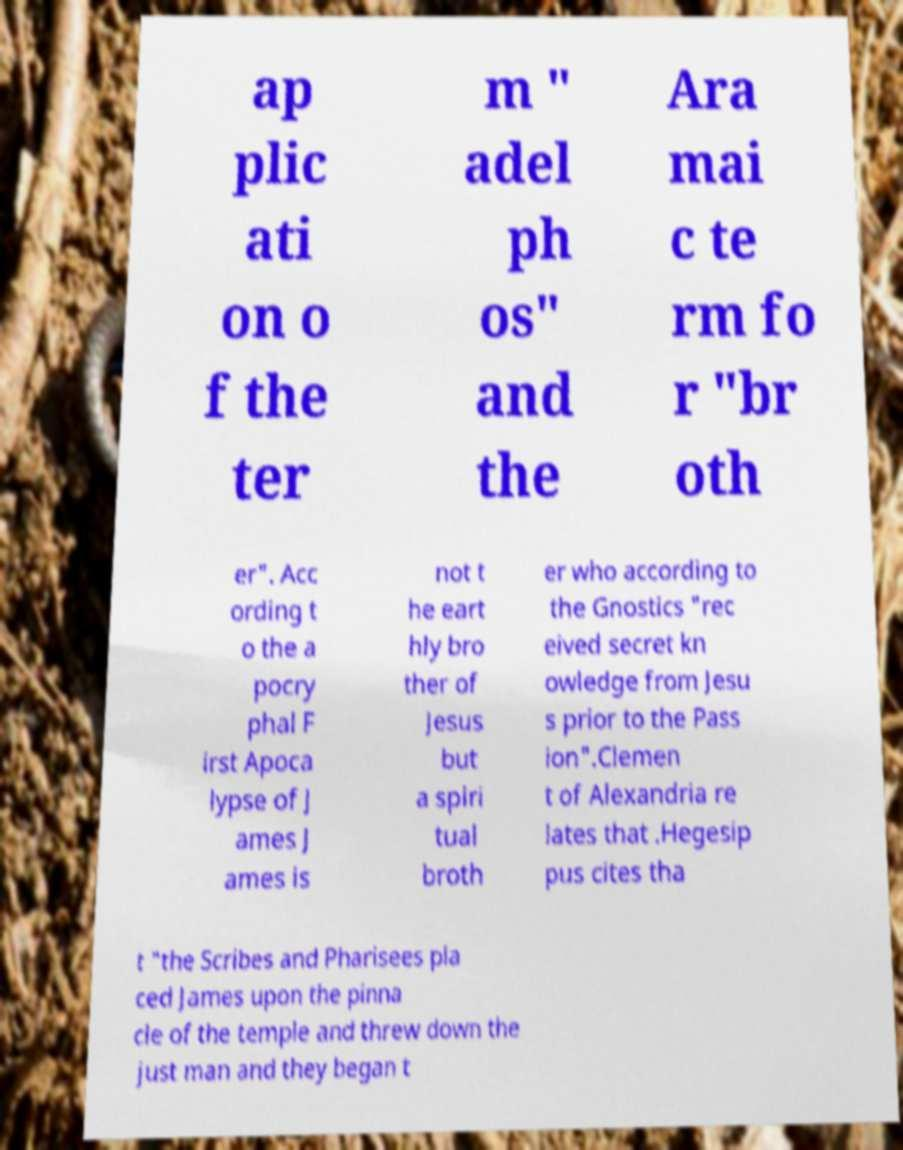Please read and relay the text visible in this image. What does it say? ap plic ati on o f the ter m " adel ph os" and the Ara mai c te rm fo r "br oth er". Acc ording t o the a pocry phal F irst Apoca lypse of J ames J ames is not t he eart hly bro ther of Jesus but a spiri tual broth er who according to the Gnostics "rec eived secret kn owledge from Jesu s prior to the Pass ion".Clemen t of Alexandria re lates that .Hegesip pus cites tha t "the Scribes and Pharisees pla ced James upon the pinna cle of the temple and threw down the just man and they began t 